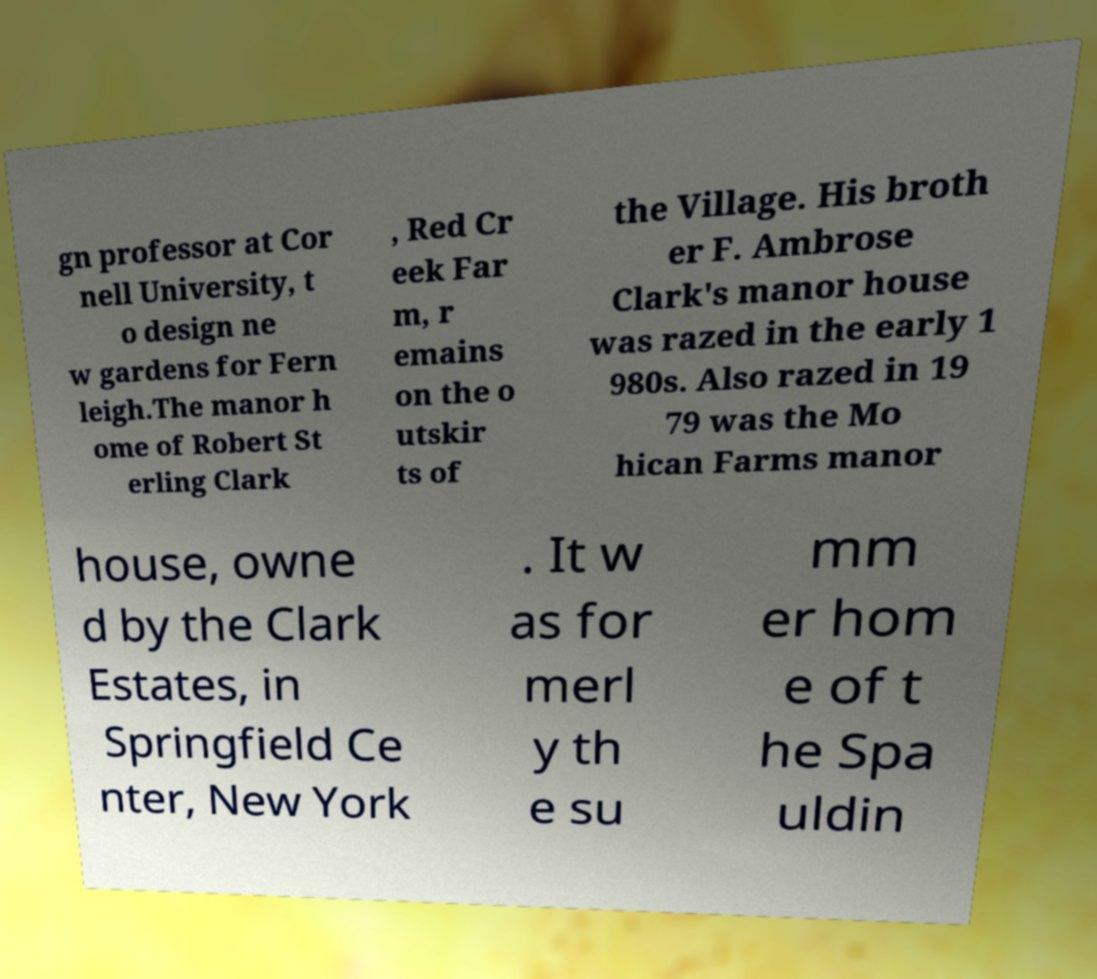For documentation purposes, I need the text within this image transcribed. Could you provide that? gn professor at Cor nell University, t o design ne w gardens for Fern leigh.The manor h ome of Robert St erling Clark , Red Cr eek Far m, r emains on the o utskir ts of the Village. His broth er F. Ambrose Clark's manor house was razed in the early 1 980s. Also razed in 19 79 was the Mo hican Farms manor house, owne d by the Clark Estates, in Springfield Ce nter, New York . It w as for merl y th e su mm er hom e of t he Spa uldin 